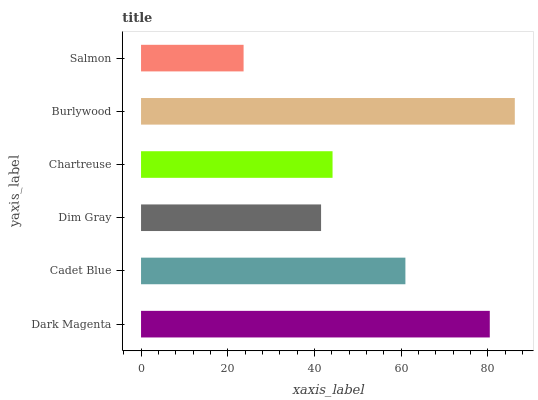Is Salmon the minimum?
Answer yes or no. Yes. Is Burlywood the maximum?
Answer yes or no. Yes. Is Cadet Blue the minimum?
Answer yes or no. No. Is Cadet Blue the maximum?
Answer yes or no. No. Is Dark Magenta greater than Cadet Blue?
Answer yes or no. Yes. Is Cadet Blue less than Dark Magenta?
Answer yes or no. Yes. Is Cadet Blue greater than Dark Magenta?
Answer yes or no. No. Is Dark Magenta less than Cadet Blue?
Answer yes or no. No. Is Cadet Blue the high median?
Answer yes or no. Yes. Is Chartreuse the low median?
Answer yes or no. Yes. Is Dark Magenta the high median?
Answer yes or no. No. Is Dim Gray the low median?
Answer yes or no. No. 